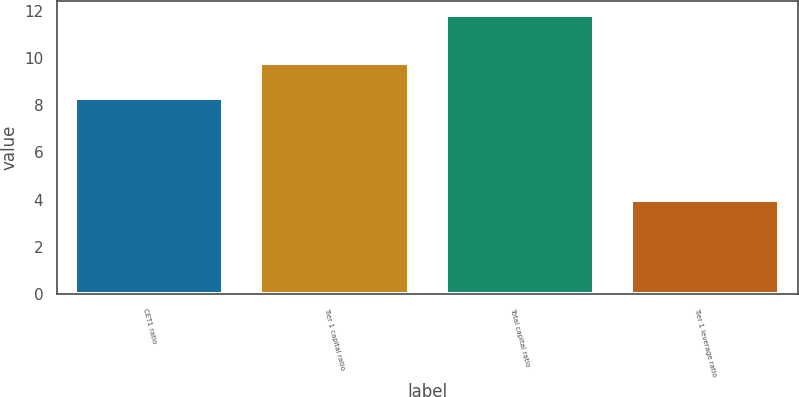Convert chart. <chart><loc_0><loc_0><loc_500><loc_500><bar_chart><fcel>CET1 ratio<fcel>Tier 1 capital ratio<fcel>Total capital ratio<fcel>Tier 1 leverage ratio<nl><fcel>8.3<fcel>9.8<fcel>11.8<fcel>4<nl></chart> 